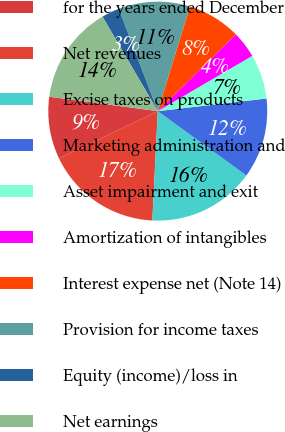Convert chart. <chart><loc_0><loc_0><loc_500><loc_500><pie_chart><fcel>for the years ended December<fcel>Net revenues<fcel>Excise taxes on products<fcel>Marketing administration and<fcel>Asset impairment and exit<fcel>Amortization of intangibles<fcel>Interest expense net (Note 14)<fcel>Provision for income taxes<fcel>Equity (income)/loss in<fcel>Net earnings<nl><fcel>9.21%<fcel>17.1%<fcel>15.79%<fcel>11.84%<fcel>6.58%<fcel>3.95%<fcel>7.89%<fcel>10.53%<fcel>2.63%<fcel>14.47%<nl></chart> 